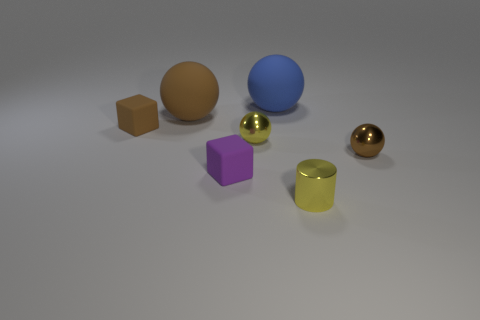Subtract all small brown metallic balls. How many balls are left? 3 Subtract all green blocks. How many brown balls are left? 2 Add 3 brown objects. How many objects exist? 10 Subtract all brown blocks. How many blocks are left? 1 Subtract all cylinders. How many objects are left? 6 Subtract all green spheres. Subtract all yellow blocks. How many spheres are left? 4 Subtract all big blue matte cylinders. Subtract all brown metallic balls. How many objects are left? 6 Add 5 cylinders. How many cylinders are left? 6 Add 4 small cyan metal cylinders. How many small cyan metal cylinders exist? 4 Subtract 0 green balls. How many objects are left? 7 